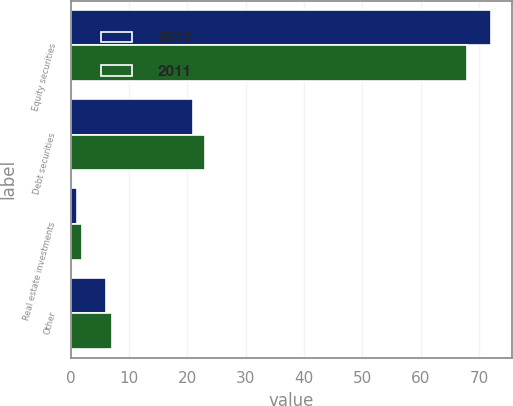<chart> <loc_0><loc_0><loc_500><loc_500><stacked_bar_chart><ecel><fcel>Equity securities<fcel>Debt securities<fcel>Real estate investments<fcel>Other<nl><fcel>2012<fcel>72<fcel>21<fcel>1<fcel>6<nl><fcel>2011<fcel>68<fcel>23<fcel>2<fcel>7<nl></chart> 